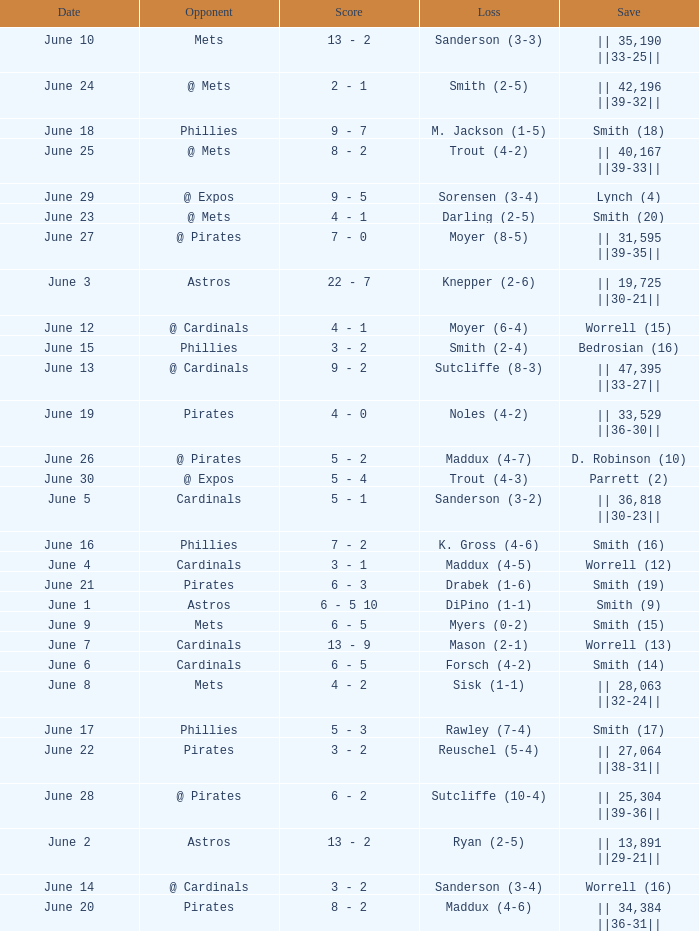The game with a loss of smith (2-4) ended with what score? 3 - 2. 